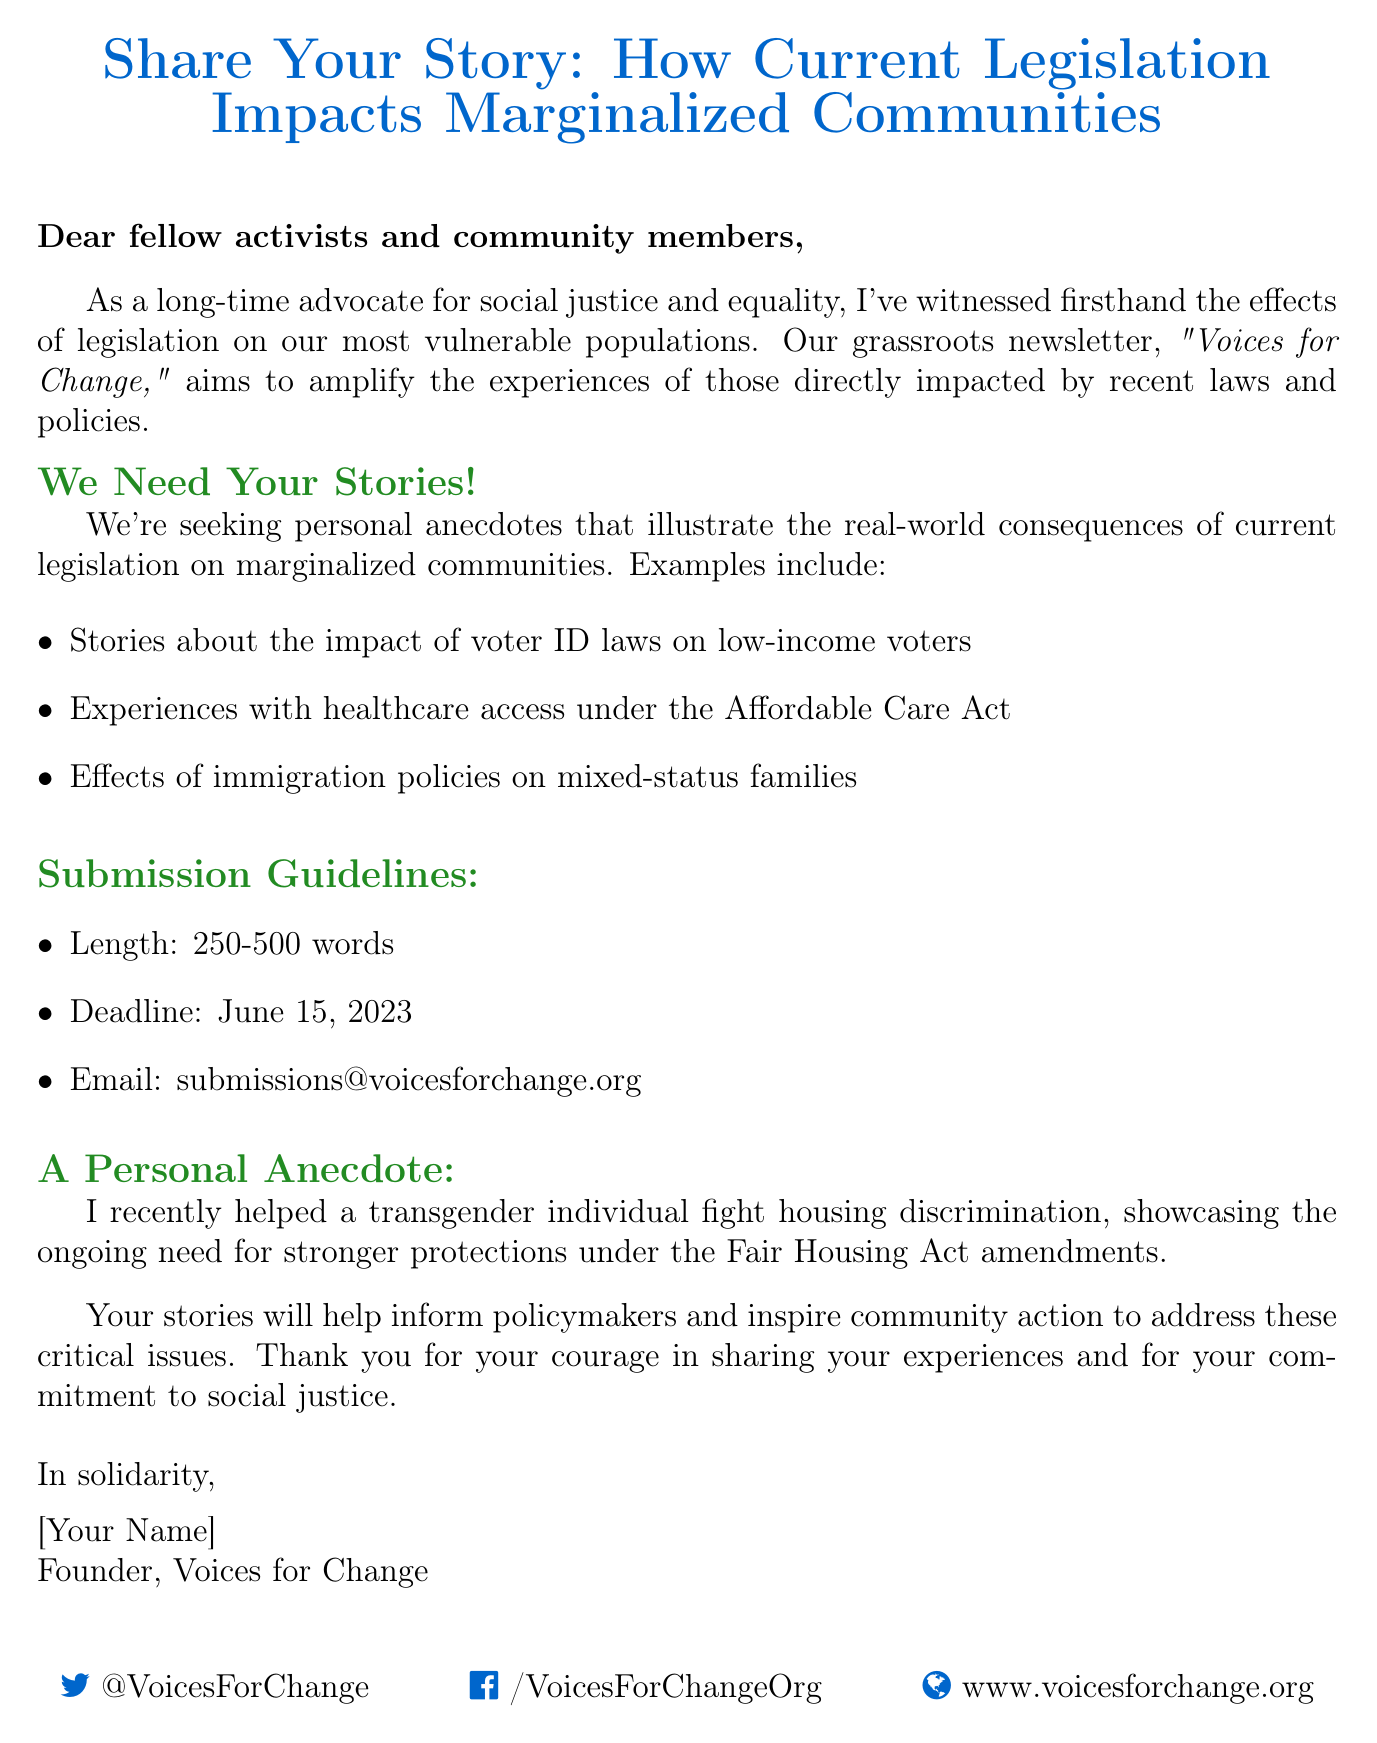What is the subject line of the email? The subject line summarizes the main topic and purpose of the email, which is to gather stories about legislation impacts.
Answer: Share Your Story: How Current Legislation Impacts Marginalized Communities What is the email address for submissions? This is the designated email provided for individuals wishing to submit their anecdotes or stories.
Answer: submissions@voicesforchange.org What is the word limit for the anecdotes? The document specifies the required length for the submissions to ensure they are concise while informative.
Answer: 250-500 words When is the submission deadline? The deadline indicates when contributors must send their stories to be considered for the newsletter.
Answer: June 15, 2023 What are the examples of stories requested? The document lists specific topics that contributors might consider when sharing their experiences related to current legislation.
Answer: Stories about the impact of voter ID laws on low-income voters How does the author describe their background? This information illustrates the author's credentials and commitment to the cause they are advocating for.
Answer: long-time advocate for social justice and equality What is the purpose of the newsletter? This explains the overall goal of the 'Voices for Change' newsletter in relation to the contributions expected from the community.
Answer: amplify the experiences of those directly impacted by recent laws and policies What personal anecdote does the author share? This anecdote highlights a specific experience relevant to the central theme of the email about marginalized communities and legislation.
Answer: I recently helped a transgender individual fight housing discrimination What will the stories help to achieve? This question addresses the impact that the shared stories are intended to have on the broader community and policymakers.
Answer: inform policymakers and inspire community action 